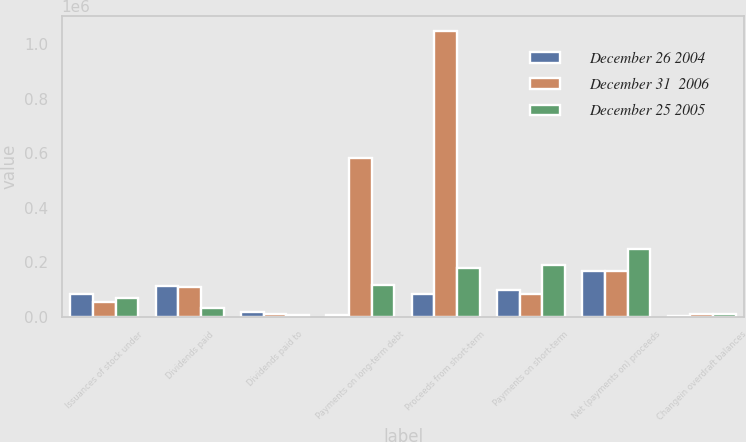Convert chart to OTSL. <chart><loc_0><loc_0><loc_500><loc_500><stacked_bar_chart><ecel><fcel>Issuances of stock under<fcel>Dividends paid<fcel>Dividends paid to<fcel>Payments on long-term debt<fcel>Proceeds from short-term<fcel>Payments on short-term<fcel>Net (payments on) proceeds<fcel>Changein overdraft balances<nl><fcel>December 26 2004<fcel>83348<fcel>110563<fcel>17790<fcel>7361<fcel>83664<fcel>98110<fcel>167379<fcel>1441<nl><fcel>December 31  2006<fcel>55229<fcel>109960<fcel>10569<fcel>584056<fcel>1.05069e+06<fcel>83664<fcel>165795<fcel>8159<nl><fcel>December 25 2005<fcel>66764<fcel>30535<fcel>7218<fcel>114629<fcel>179957<fcel>188718<fcel>250000<fcel>8715<nl></chart> 